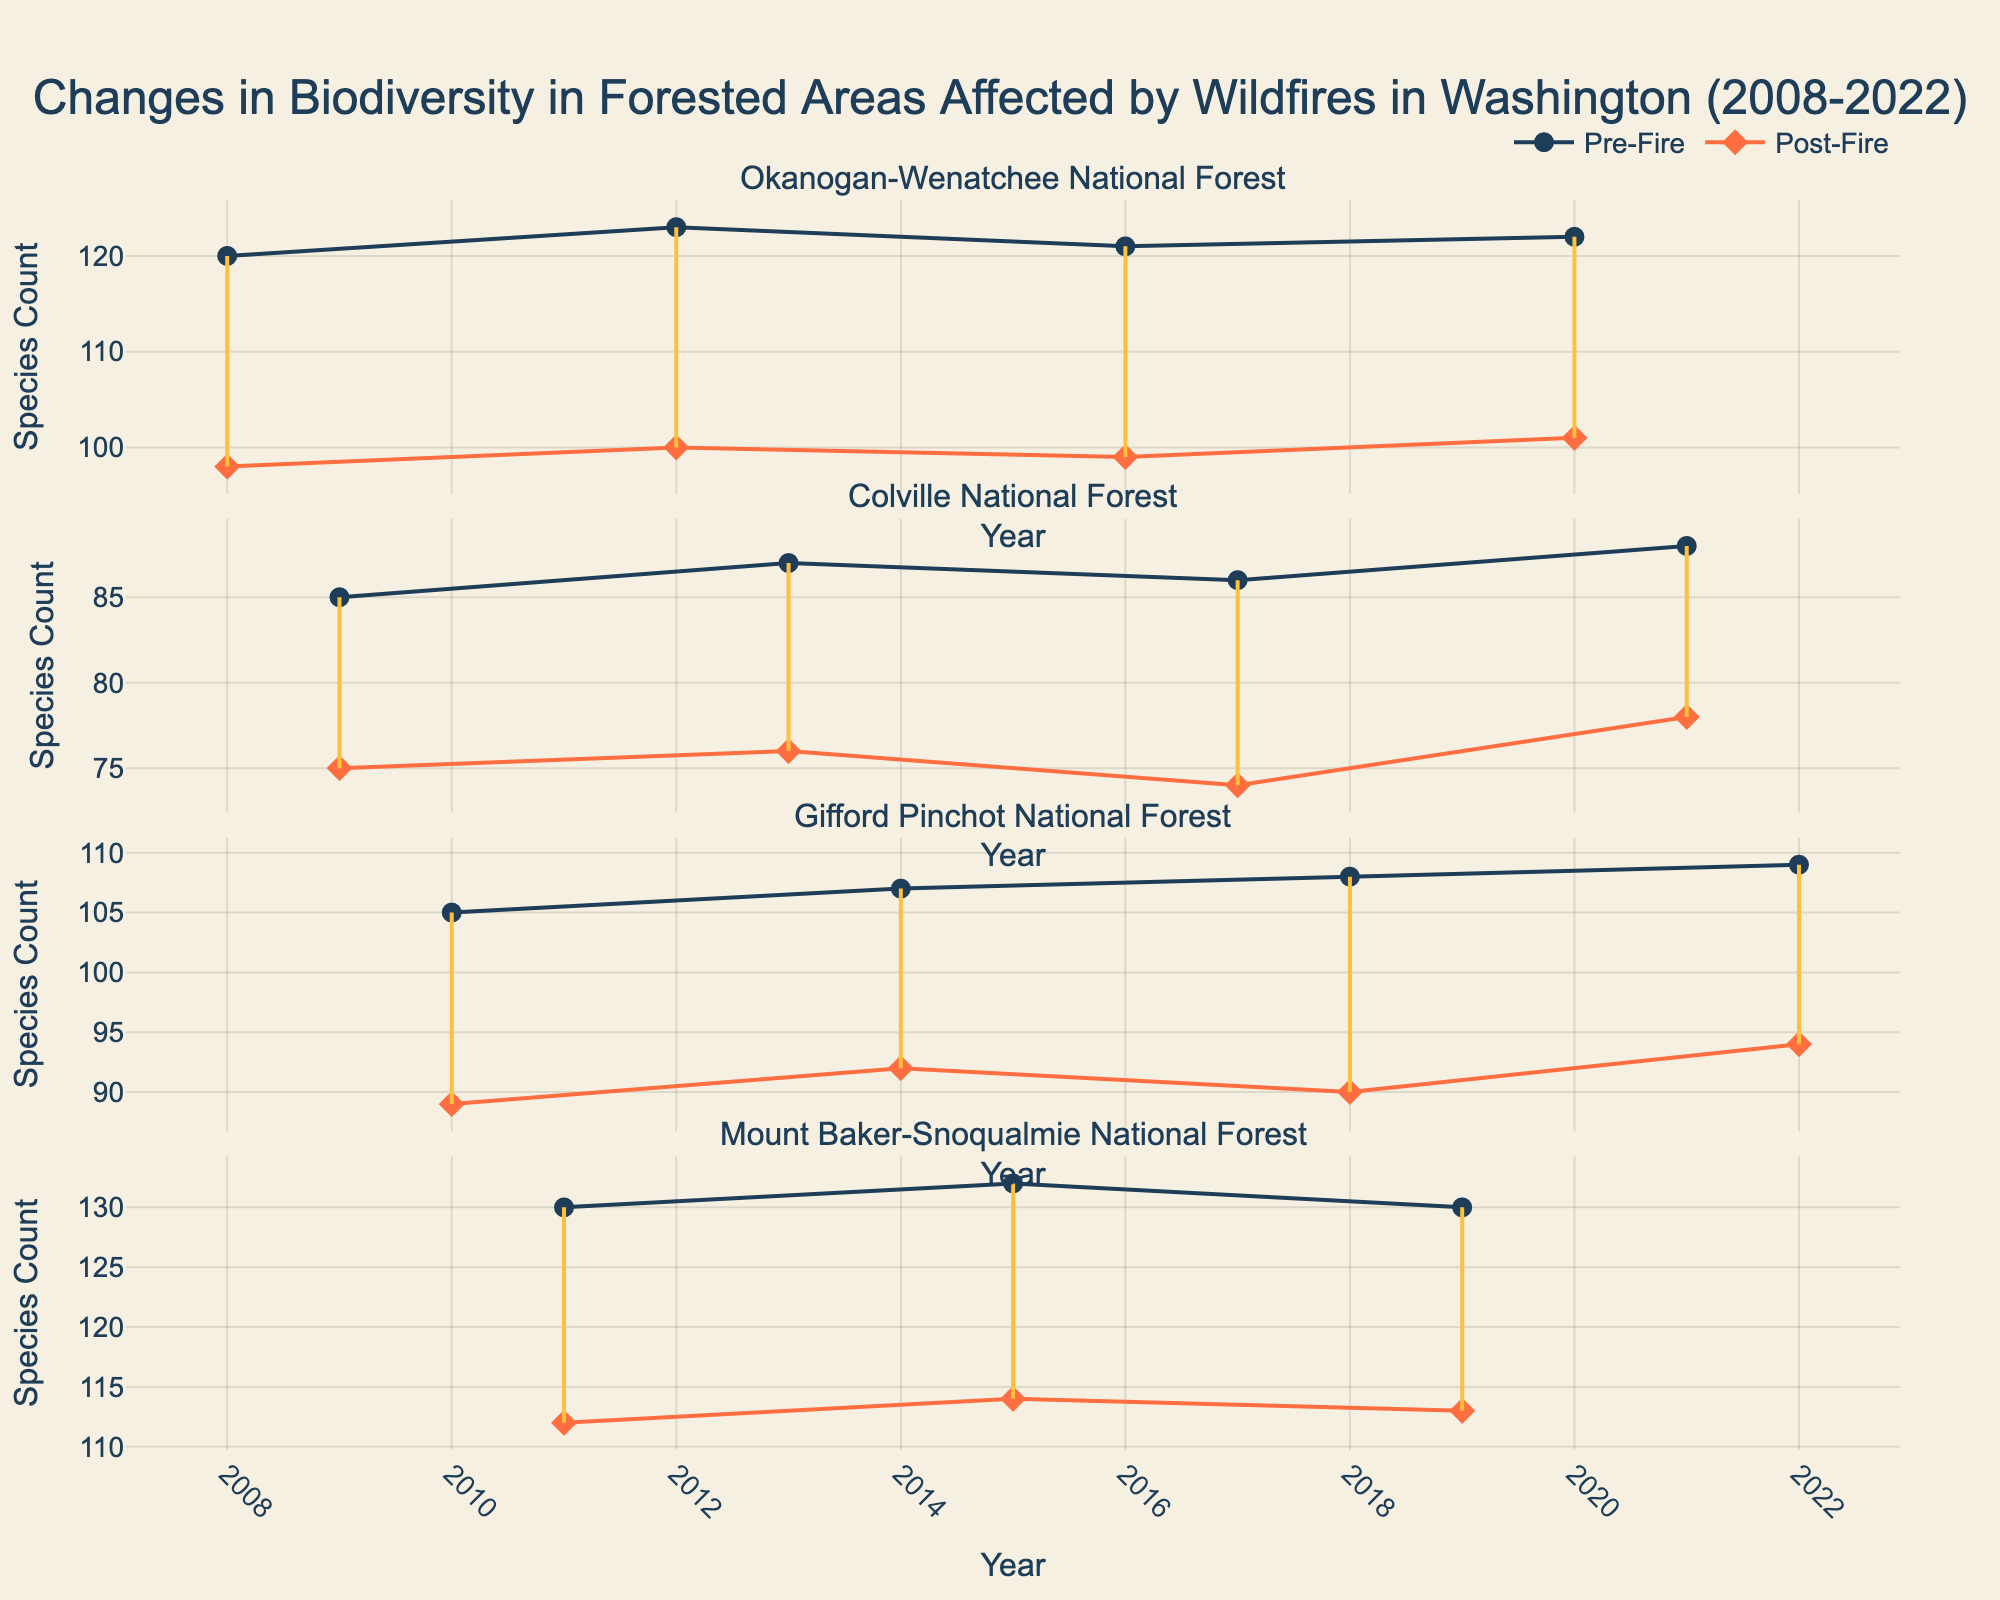What is the title of the plot? The title of the plot is text displayed prominently at the top of the plot box. It is often used to provide the main subject or focus of the plot.
Answer: Changes in Biodiversity in Forested Areas Affected by Wildfires in Washington (2008-2022) How many subplots are there in the figure? Count the number of separate rows in the plot; each row represents a different location.
Answer: Four Which location has the least difference in species count between pre-fire and post-fire in 2015? Identify the year 2015, find the corresponding subplot for different locations, and compare the differences between pre- and post-fire counts.
Answer: Mount Baker-Snoqualmie National Forest What is the trend in post-fire species count in Gifford Pinchot National Forest from 2012 to 2022? Look at the data points connected by lines for post-fire species count in Gifford Pinchot National Forest and observe the pattern over the years from 2012 to 2022.
Answer: Increasing By how many species did the biodiversity decrease in Okanogan-Wenatchee National Forest in 2020? Locate the pre-fire and post-fire species counts for Okanogan-Wenatchee National Forest in 2020 and calculate the difference: 122 and 101.
Answer: 21 Which year shows the highest post-fire species count in Mount Baker-Snoqualmie National Forest? Observe the post-fire data points in the Mount Baker-Snoqualmie National Forest subplot and identify the highest value along the y-axis.
Answer: 2015 Which forest shows a consistent decrease in both pre-fire and post-fire species counts over the years? Analyze the trends for all the subplots individually and look for consistently decreasing patterns in both counts.
Answer: Colville National Forest What is the average pre-fire species count in Gifford Pinchot National Forest over the 15 years? List pre-fire species counts for Gifford Pinchot National Forest from 2010 to 2022, sum them up and divide by the number of years (4 data points).
Answer: 107.25 Which location shows the most significant improvement in post-fire biodiversity from 2020 to 2021? Compare post-fire species counts between 2020 and 2021 for all subplots and identify which location has the biggest positive difference.
Answer: Colville National Forest 